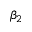Convert formula to latex. <formula><loc_0><loc_0><loc_500><loc_500>\beta _ { 2 }</formula> 